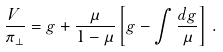Convert formula to latex. <formula><loc_0><loc_0><loc_500><loc_500>\frac { V } { \pi _ { \perp } } = g + \frac { \mu } { 1 - \mu } \left [ g - \int \frac { d g } { \mu } \right ] \, .</formula> 